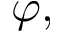Convert formula to latex. <formula><loc_0><loc_0><loc_500><loc_500>\varphi ,</formula> 